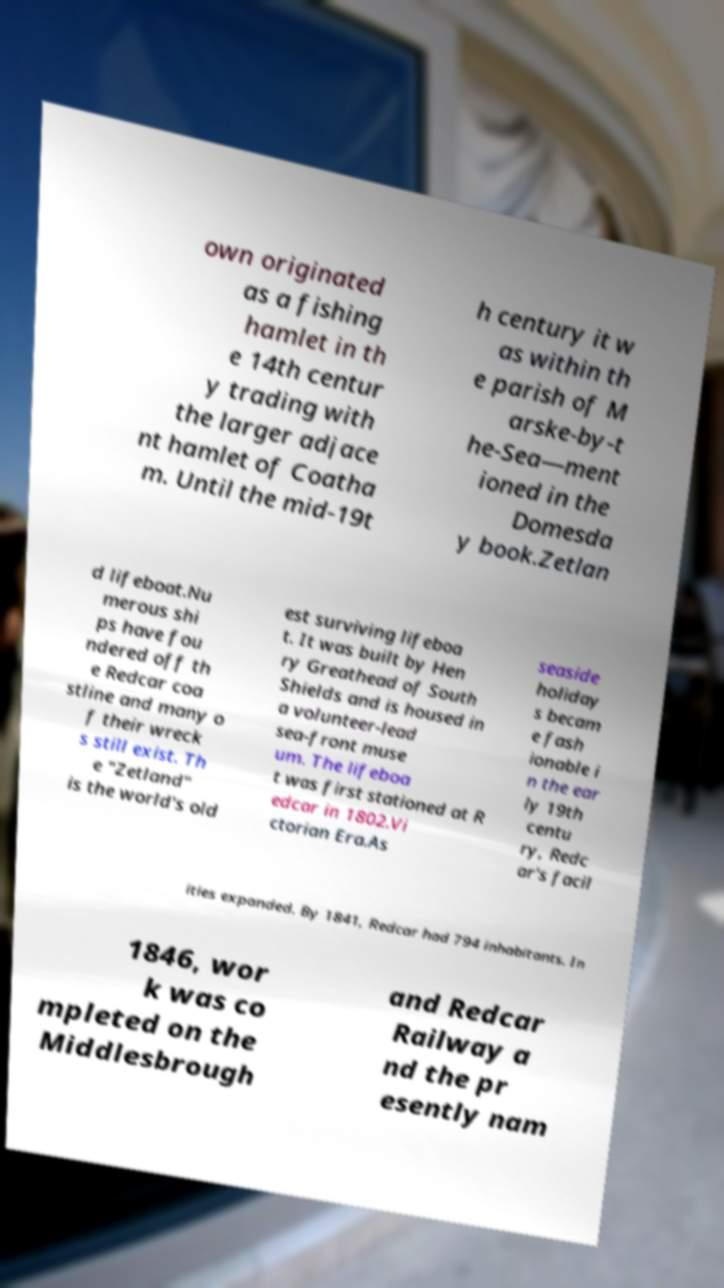There's text embedded in this image that I need extracted. Can you transcribe it verbatim? own originated as a fishing hamlet in th e 14th centur y trading with the larger adjace nt hamlet of Coatha m. Until the mid-19t h century it w as within th e parish of M arske-by-t he-Sea—ment ioned in the Domesda y book.Zetlan d lifeboat.Nu merous shi ps have fou ndered off th e Redcar coa stline and many o f their wreck s still exist. Th e "Zetland" is the world's old est surviving lifeboa t. It was built by Hen ry Greathead of South Shields and is housed in a volunteer-lead sea-front muse um. The lifeboa t was first stationed at R edcar in 1802.Vi ctorian Era.As seaside holiday s becam e fash ionable i n the ear ly 19th centu ry, Redc ar's facil ities expanded. By 1841, Redcar had 794 inhabitants. In 1846, wor k was co mpleted on the Middlesbrough and Redcar Railway a nd the pr esently nam 